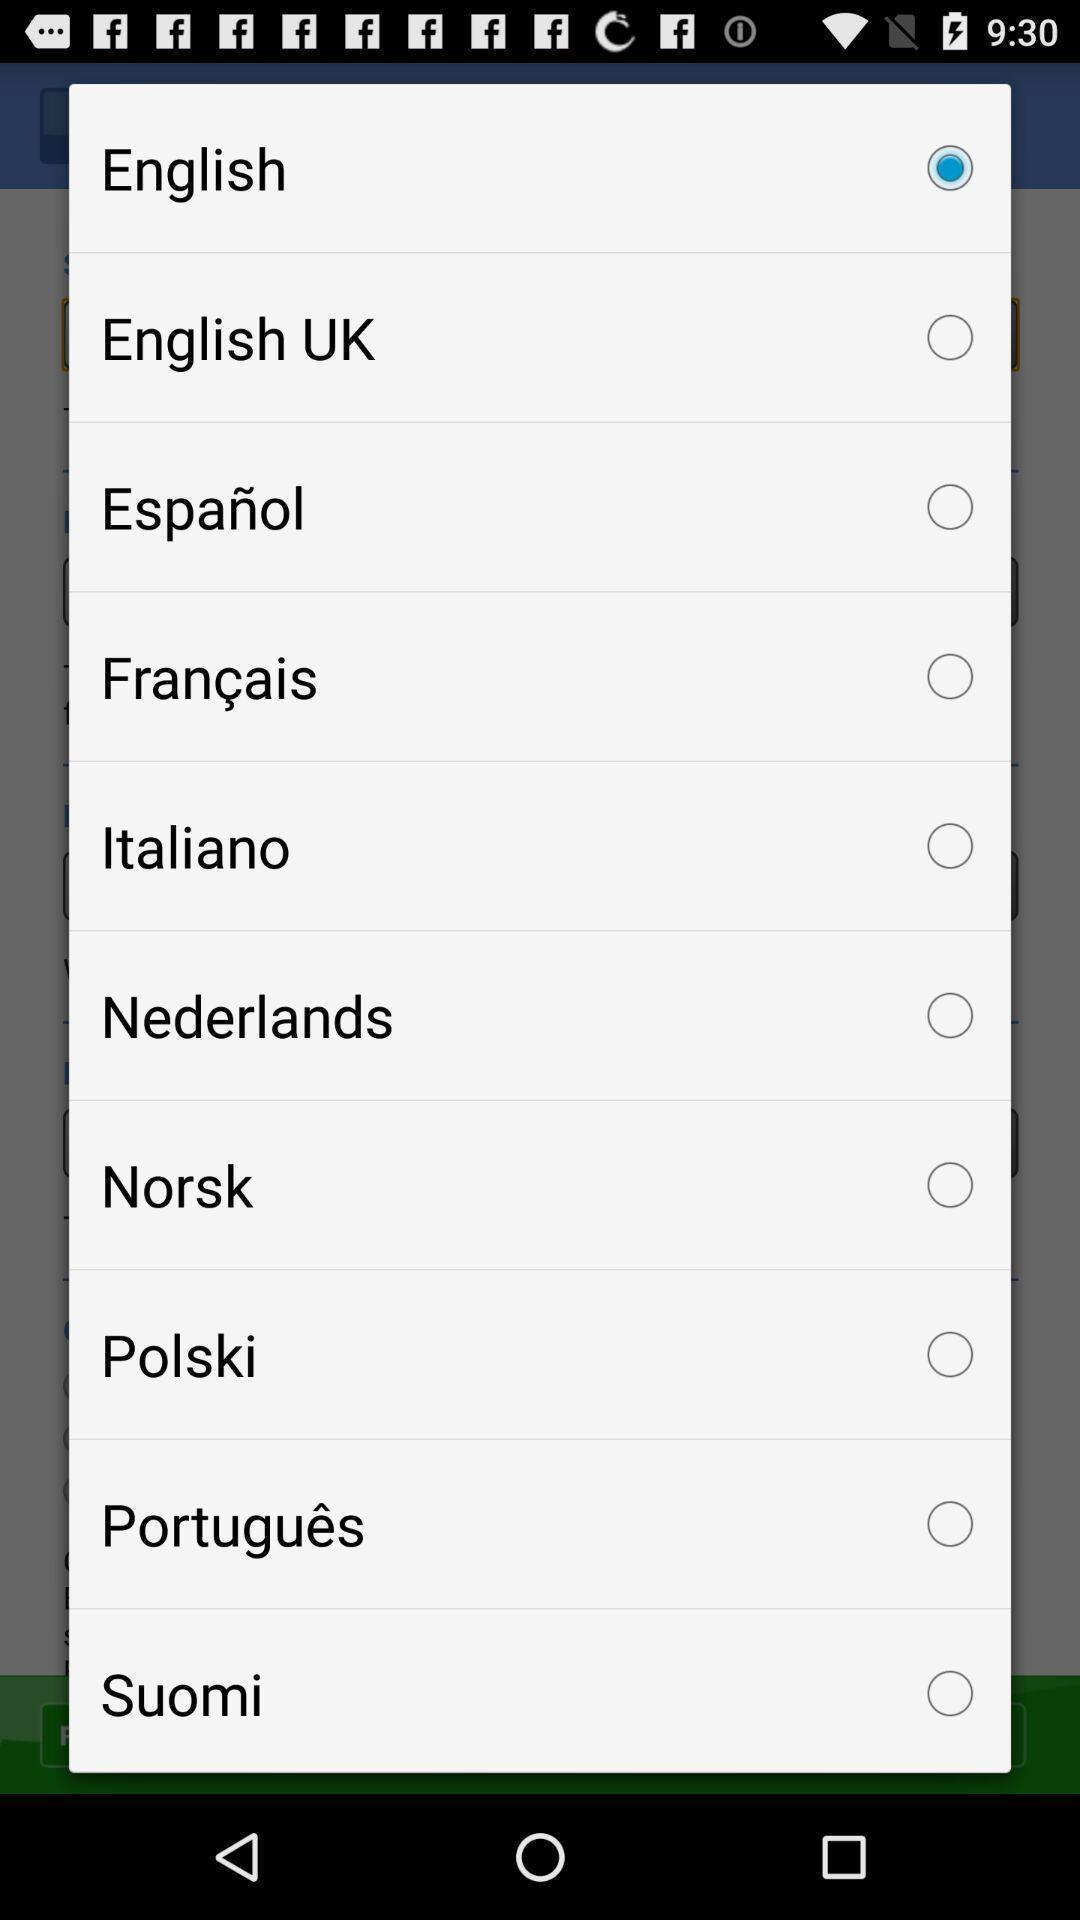Tell me what you see in this picture. Pop-up showing list of different languages. 